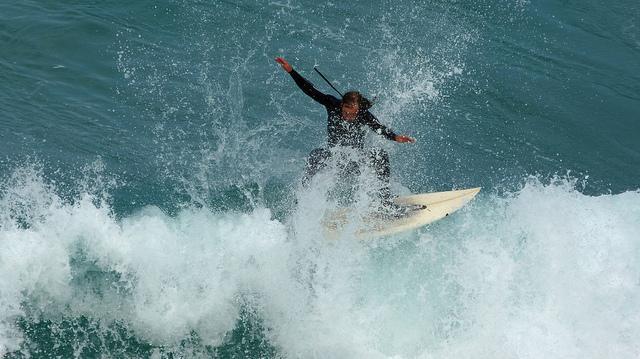How many chairs are at each table?
Give a very brief answer. 0. 